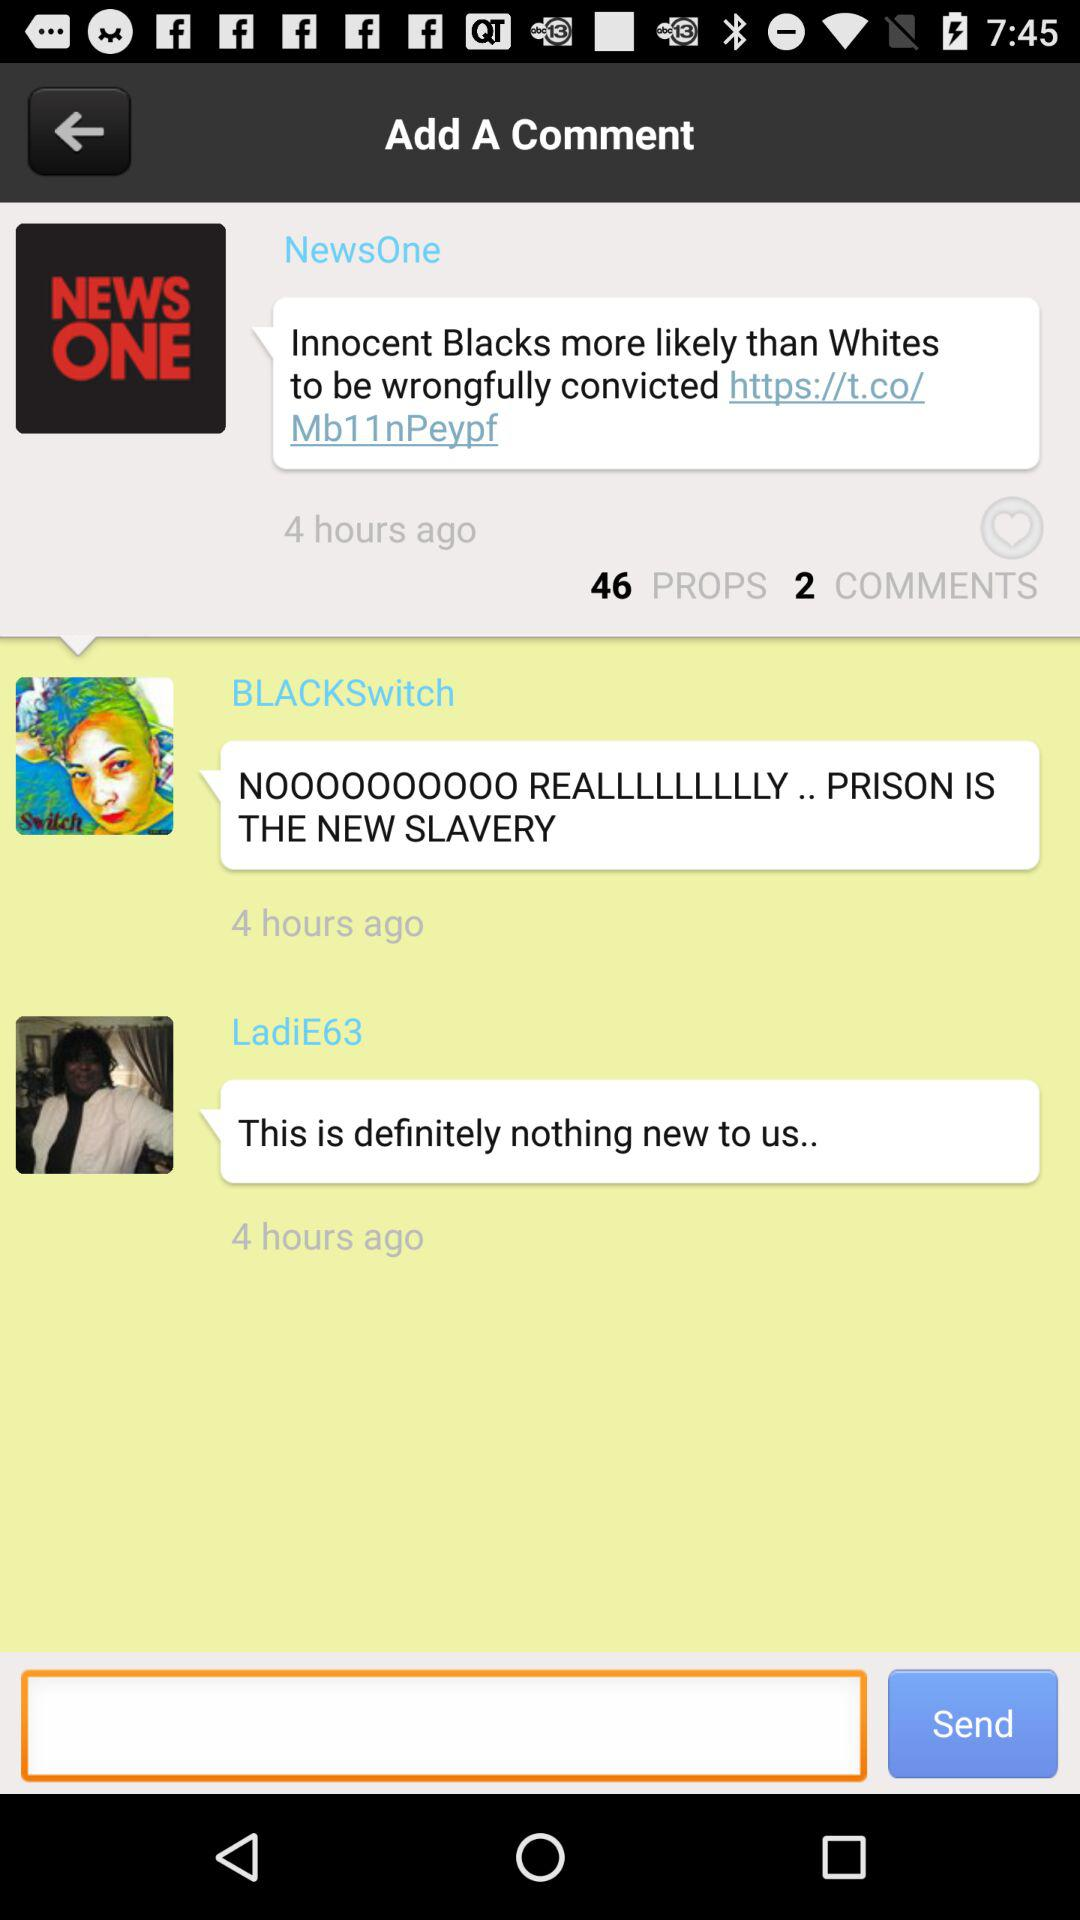How many hours ago did NewsOne comment? NewsOne commented 4 hours ago. 